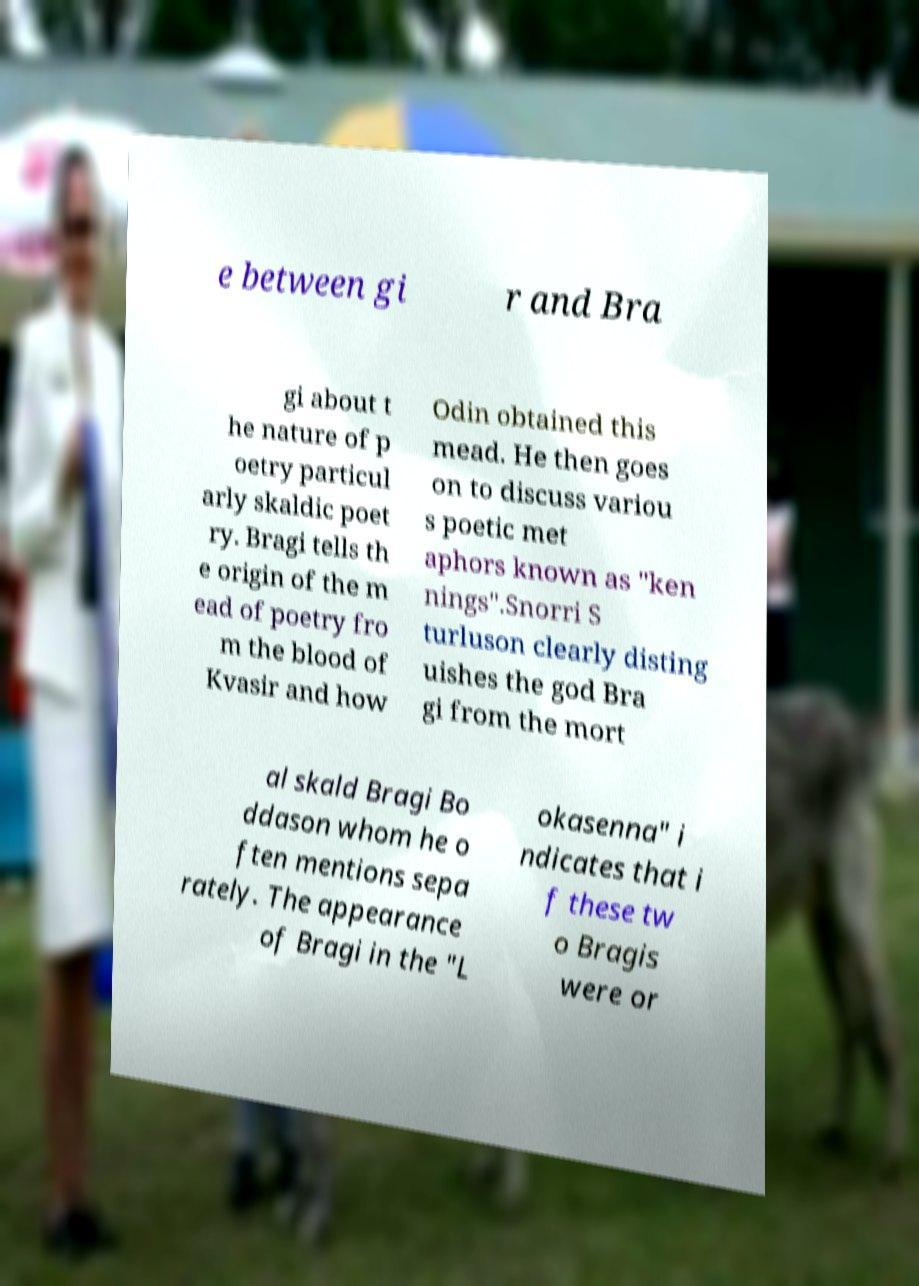Could you extract and type out the text from this image? e between gi r and Bra gi about t he nature of p oetry particul arly skaldic poet ry. Bragi tells th e origin of the m ead of poetry fro m the blood of Kvasir and how Odin obtained this mead. He then goes on to discuss variou s poetic met aphors known as "ken nings".Snorri S turluson clearly disting uishes the god Bra gi from the mort al skald Bragi Bo ddason whom he o ften mentions sepa rately. The appearance of Bragi in the "L okasenna" i ndicates that i f these tw o Bragis were or 